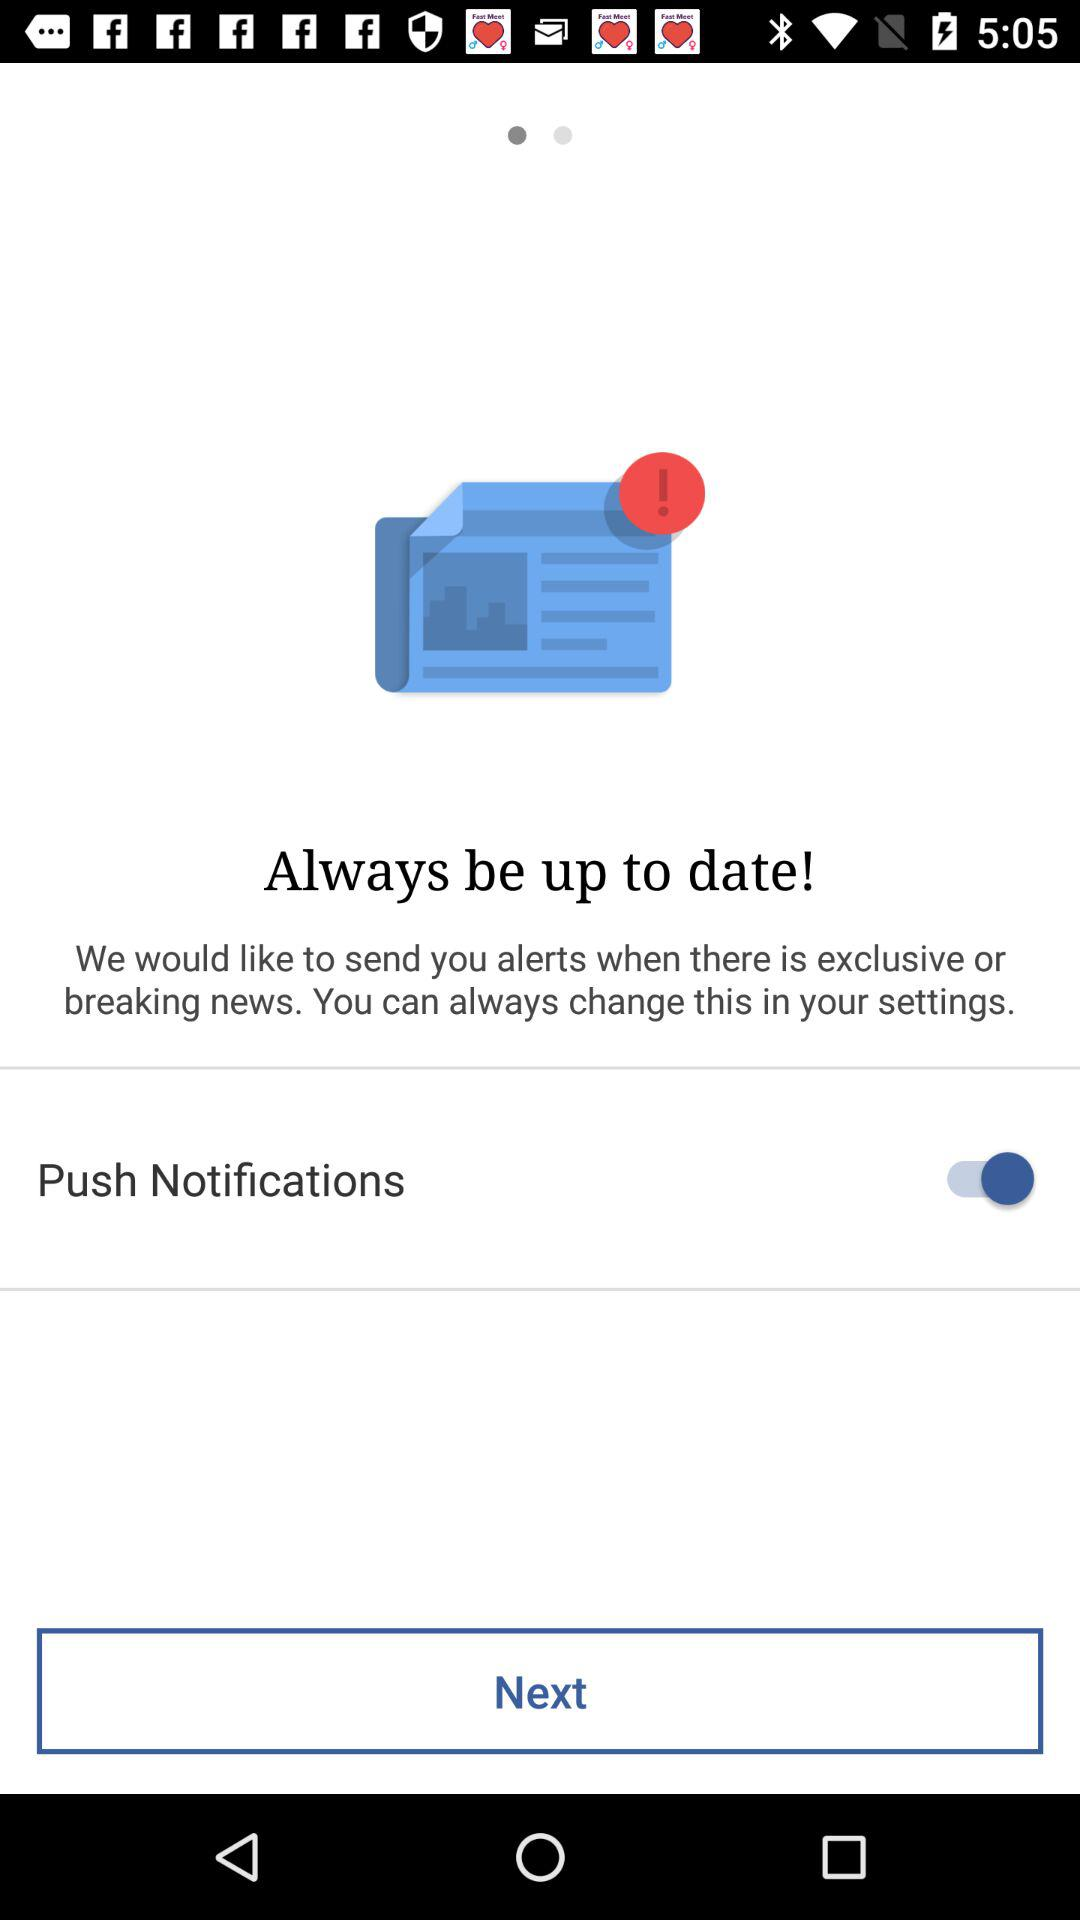What is the status of "Push Notifications"? The status is "on". 